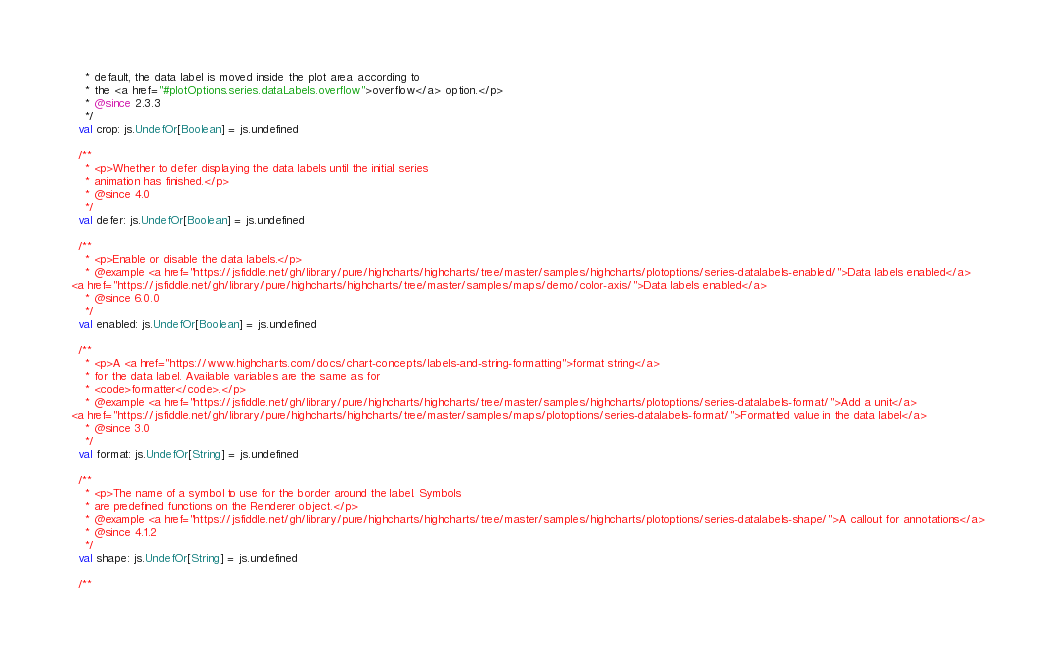Convert code to text. <code><loc_0><loc_0><loc_500><loc_500><_Scala_>    * default, the data label is moved inside the plot area according to
    * the <a href="#plotOptions.series.dataLabels.overflow">overflow</a> option.</p>
    * @since 2.3.3
    */
  val crop: js.UndefOr[Boolean] = js.undefined

  /**
    * <p>Whether to defer displaying the data labels until the initial series
    * animation has finished.</p>
    * @since 4.0
    */
  val defer: js.UndefOr[Boolean] = js.undefined

  /**
    * <p>Enable or disable the data labels.</p>
    * @example <a href="https://jsfiddle.net/gh/library/pure/highcharts/highcharts/tree/master/samples/highcharts/plotoptions/series-datalabels-enabled/">Data labels enabled</a>
<a href="https://jsfiddle.net/gh/library/pure/highcharts/highcharts/tree/master/samples/maps/demo/color-axis/">Data labels enabled</a>
    * @since 6.0.0
    */
  val enabled: js.UndefOr[Boolean] = js.undefined

  /**
    * <p>A <a href="https://www.highcharts.com/docs/chart-concepts/labels-and-string-formatting">format string</a>
    * for the data label. Available variables are the same as for
    * <code>formatter</code>.</p>
    * @example <a href="https://jsfiddle.net/gh/library/pure/highcharts/highcharts/tree/master/samples/highcharts/plotoptions/series-datalabels-format/">Add a unit</a>
<a href="https://jsfiddle.net/gh/library/pure/highcharts/highcharts/tree/master/samples/maps/plotoptions/series-datalabels-format/">Formatted value in the data label</a>
    * @since 3.0
    */
  val format: js.UndefOr[String] = js.undefined

  /**
    * <p>The name of a symbol to use for the border around the label. Symbols
    * are predefined functions on the Renderer object.</p>
    * @example <a href="https://jsfiddle.net/gh/library/pure/highcharts/highcharts/tree/master/samples/highcharts/plotoptions/series-datalabels-shape/">A callout for annotations</a>
    * @since 4.1.2
    */
  val shape: js.UndefOr[String] = js.undefined

  /**</code> 